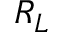<formula> <loc_0><loc_0><loc_500><loc_500>R _ { L }</formula> 